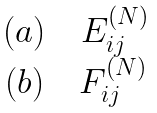Convert formula to latex. <formula><loc_0><loc_0><loc_500><loc_500>\begin{matrix} ( a ) \quad E _ { i j } ^ { ( N ) } \\ ( b ) \quad F _ { i j } ^ { ( N ) } \end{matrix}</formula> 